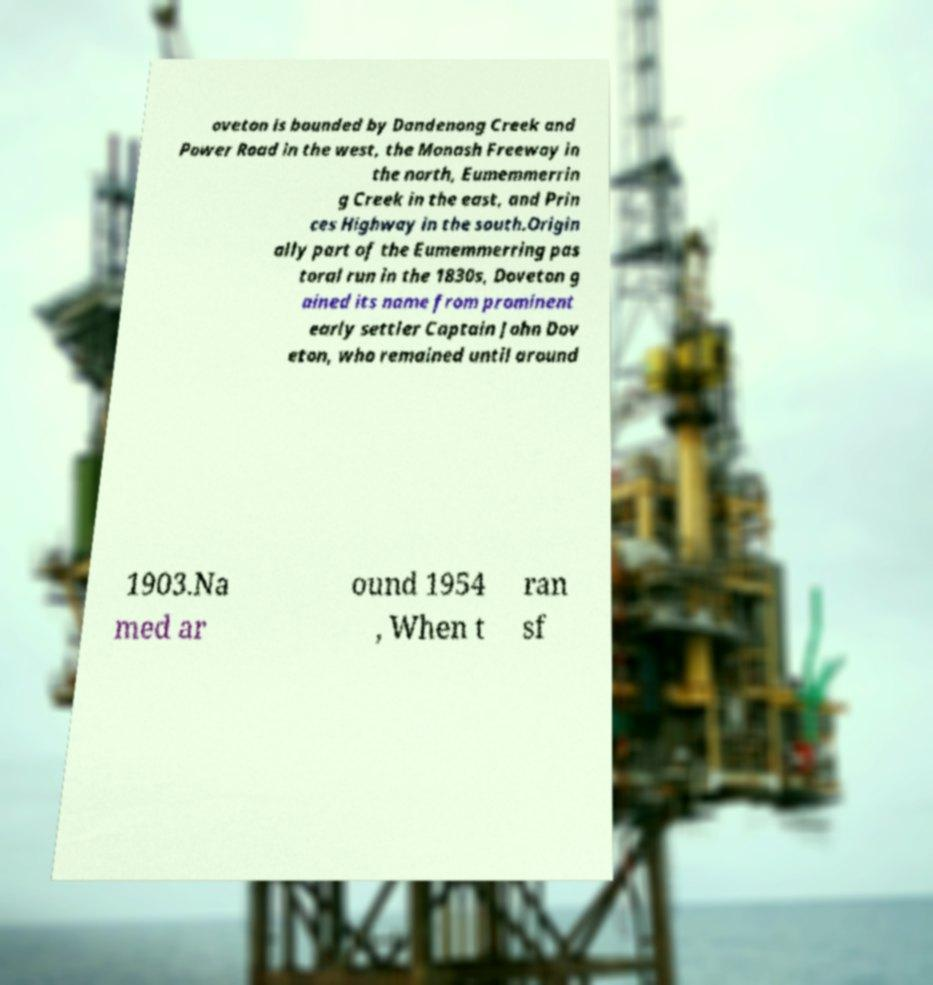There's text embedded in this image that I need extracted. Can you transcribe it verbatim? oveton is bounded by Dandenong Creek and Power Road in the west, the Monash Freeway in the north, Eumemmerrin g Creek in the east, and Prin ces Highway in the south.Origin ally part of the Eumemmerring pas toral run in the 1830s, Doveton g ained its name from prominent early settler Captain John Dov eton, who remained until around 1903.Na med ar ound 1954 , When t ran sf 